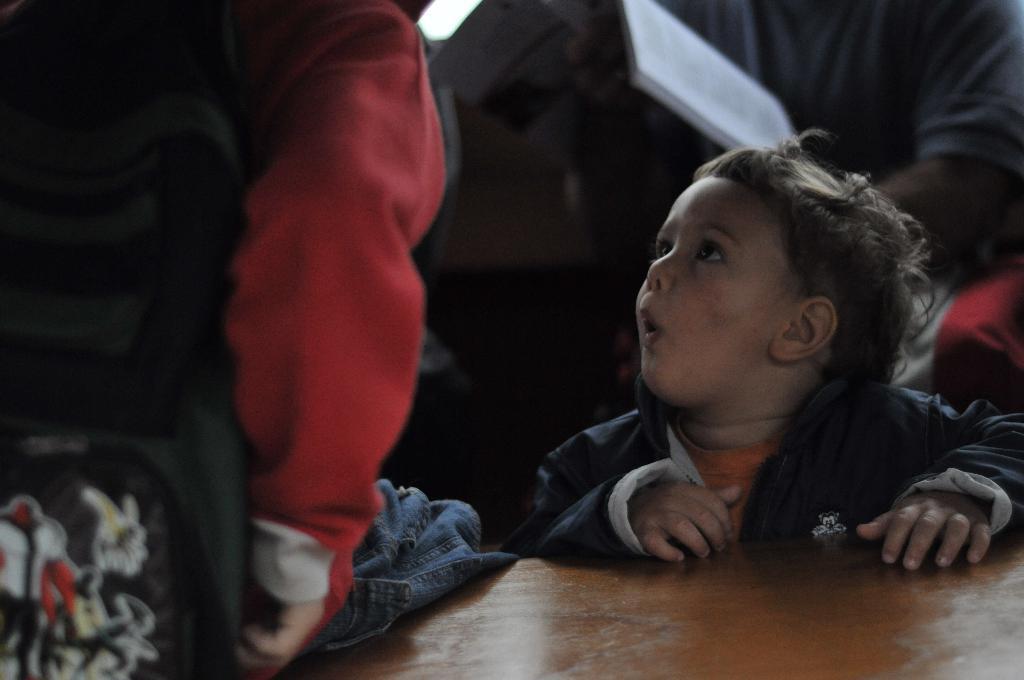How would you summarize this image in a sentence or two? In this picture we can see some people, brag, book, wooden surface and some objects. 